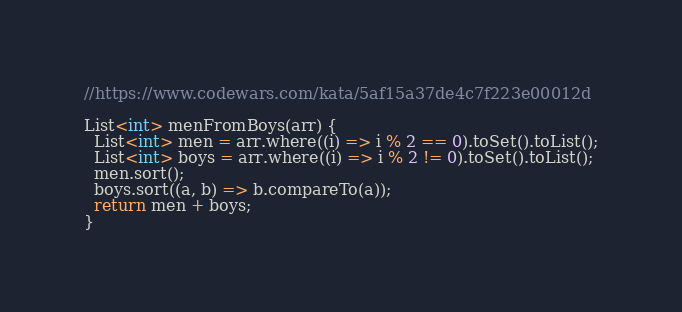<code> <loc_0><loc_0><loc_500><loc_500><_Dart_>//https://www.codewars.com/kata/5af15a37de4c7f223e00012d

List<int> menFromBoys(arr) {
  List<int> men = arr.where((i) => i % 2 == 0).toSet().toList();
  List<int> boys = arr.where((i) => i % 2 != 0).toSet().toList();
  men.sort();
  boys.sort((a, b) => b.compareTo(a));
  return men + boys;
}
</code> 